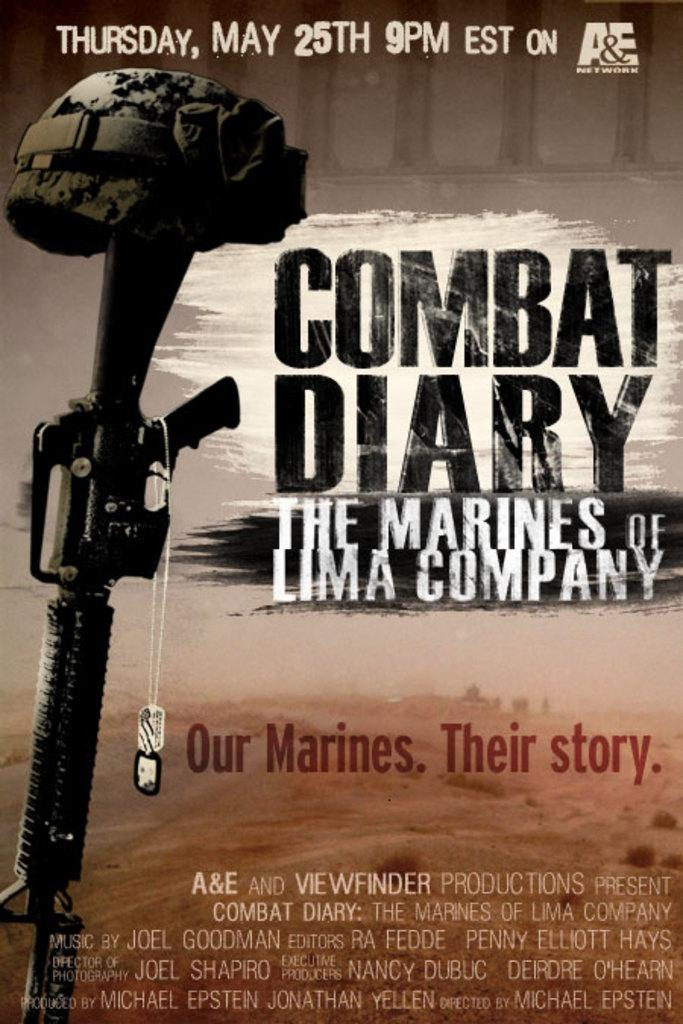What is featured on the poster in the image? The poster has a picture of a gun. What else can be seen on the poster besides the image? There is text on the poster. What type of stamp is visible on the gun in the image? There is no stamp visible on the gun in the image; it is a picture of a gun on the poster. What is the texture of the poster in the image? The texture of the poster cannot be determined from the image alone. 